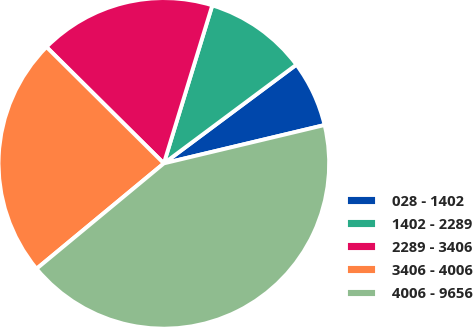<chart> <loc_0><loc_0><loc_500><loc_500><pie_chart><fcel>028 - 1402<fcel>1402 - 2289<fcel>2289 - 3406<fcel>3406 - 4006<fcel>4006 - 9656<nl><fcel>6.46%<fcel>10.08%<fcel>17.3%<fcel>23.44%<fcel>42.72%<nl></chart> 